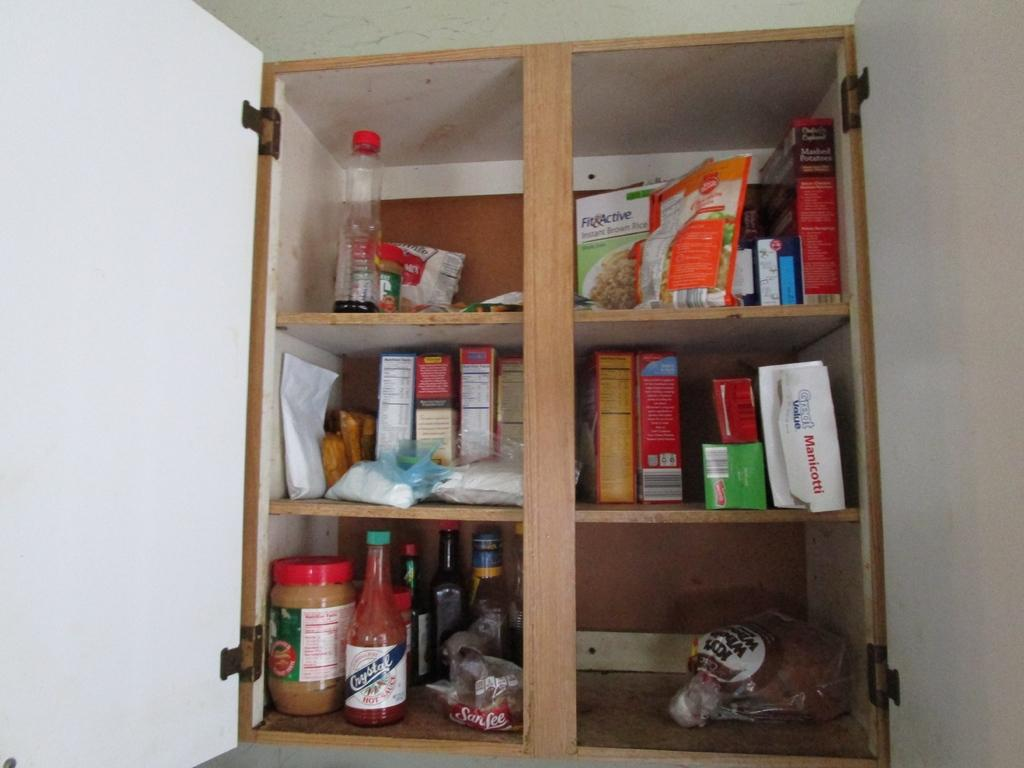What type of furniture is present in the image? There is a cabinet in the image. What can be found inside the cabinet? The cabinet contains bottles and boxes of food items. What is the color of the cabinet door? The cabinet has a white door. How many babies are sleeping quietly in the image? There are no babies present in the image, and therefore no sleeping or quietness can be observed. What type of oatmeal is being prepared in the image? There is no oatmeal or preparation process visible in the image. 